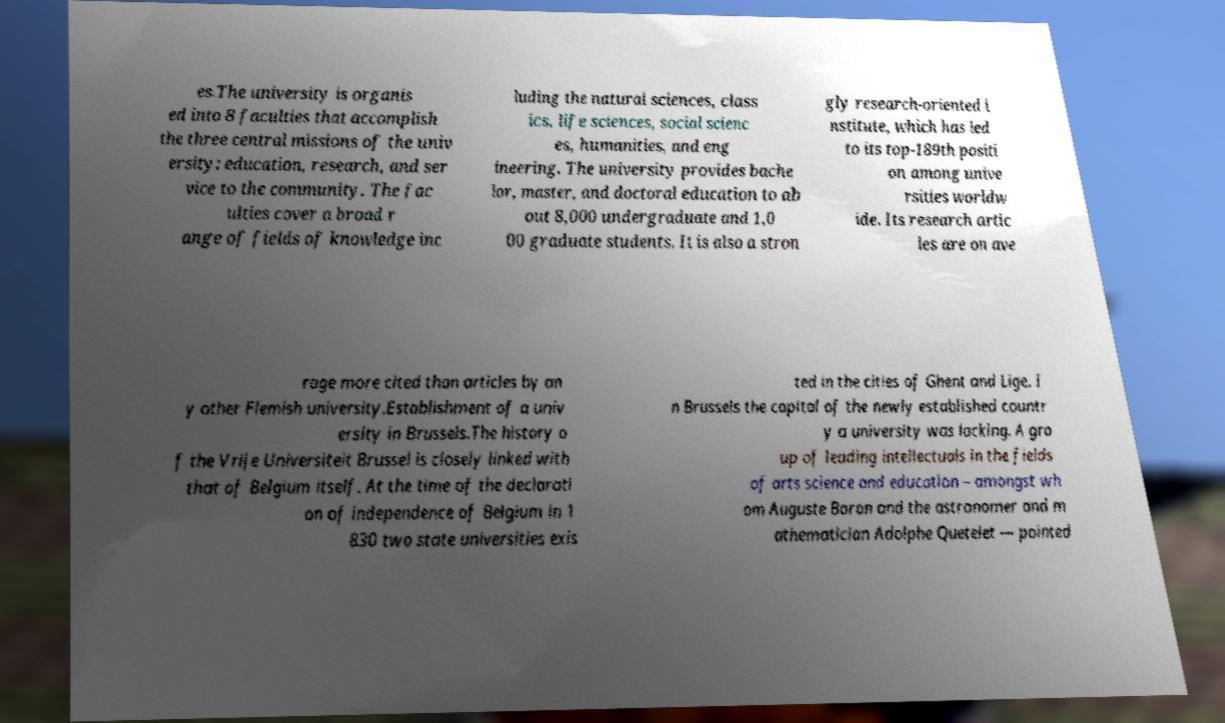Please read and relay the text visible in this image. What does it say? es.The university is organis ed into 8 faculties that accomplish the three central missions of the univ ersity: education, research, and ser vice to the community. The fac ulties cover a broad r ange of fields of knowledge inc luding the natural sciences, class ics, life sciences, social scienc es, humanities, and eng ineering. The university provides bache lor, master, and doctoral education to ab out 8,000 undergraduate and 1,0 00 graduate students. It is also a stron gly research-oriented i nstitute, which has led to its top-189th positi on among unive rsities worldw ide. Its research artic les are on ave rage more cited than articles by an y other Flemish university.Establishment of a univ ersity in Brussels.The history o f the Vrije Universiteit Brussel is closely linked with that of Belgium itself. At the time of the declarati on of independence of Belgium in 1 830 two state universities exis ted in the cities of Ghent and Lige. I n Brussels the capital of the newly established countr y a university was lacking. A gro up of leading intellectuals in the fields of arts science and education – amongst wh om Auguste Baron and the astronomer and m athematician Adolphe Quetelet — pointed 